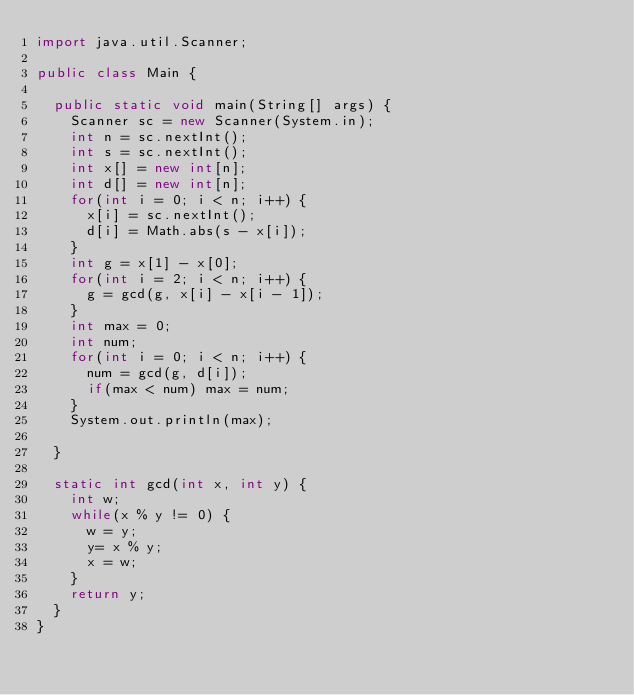<code> <loc_0><loc_0><loc_500><loc_500><_Java_>import java.util.Scanner;

public class Main {

	public static void main(String[] args) {
		Scanner sc = new Scanner(System.in);
		int n = sc.nextInt();
		int s = sc.nextInt();
		int x[] = new int[n];
		int d[] = new int[n];
		for(int i = 0; i < n; i++) { 
			x[i] = sc.nextInt();
			d[i] = Math.abs(s - x[i]);
		}
		int g = x[1] - x[0];
		for(int i = 2; i < n; i++) {
			g = gcd(g, x[i] - x[i - 1]);
		}
		int max = 0;
		int num;
		for(int i = 0; i < n; i++) {
			num = gcd(g, d[i]);
			if(max < num) max = num;
		}
		System.out.println(max);
		
	}
	
	static int gcd(int x, int y) {
		int w;
		while(x % y != 0) {
			w = y;
			y= x % y;
			x = w;
		}
		return y;
	}
}</code> 